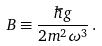Convert formula to latex. <formula><loc_0><loc_0><loc_500><loc_500>B \equiv \frac { \hbar { g } } { 2 m ^ { 2 } \omega ^ { 3 } } \, .</formula> 